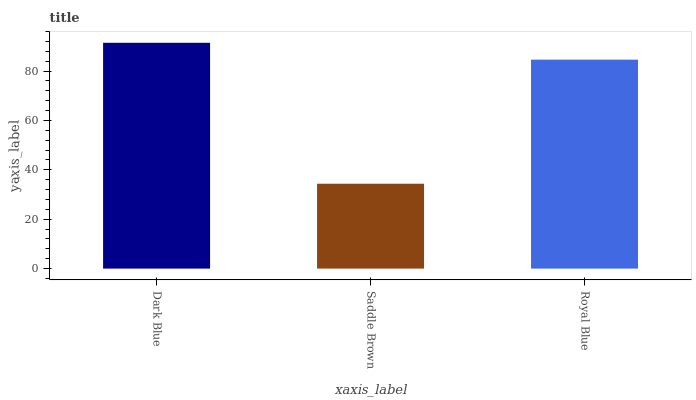Is Saddle Brown the minimum?
Answer yes or no. Yes. Is Dark Blue the maximum?
Answer yes or no. Yes. Is Royal Blue the minimum?
Answer yes or no. No. Is Royal Blue the maximum?
Answer yes or no. No. Is Royal Blue greater than Saddle Brown?
Answer yes or no. Yes. Is Saddle Brown less than Royal Blue?
Answer yes or no. Yes. Is Saddle Brown greater than Royal Blue?
Answer yes or no. No. Is Royal Blue less than Saddle Brown?
Answer yes or no. No. Is Royal Blue the high median?
Answer yes or no. Yes. Is Royal Blue the low median?
Answer yes or no. Yes. Is Saddle Brown the high median?
Answer yes or no. No. Is Dark Blue the low median?
Answer yes or no. No. 